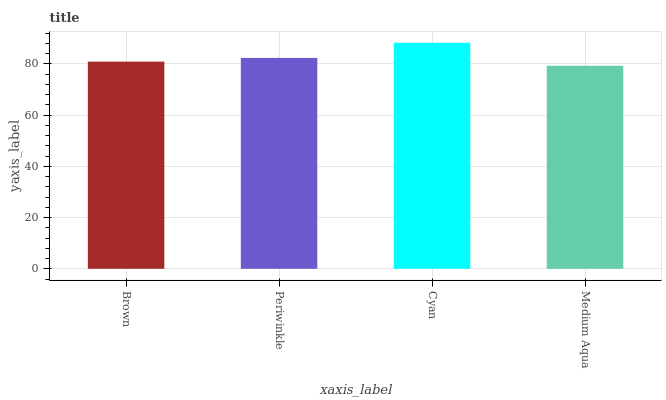Is Medium Aqua the minimum?
Answer yes or no. Yes. Is Cyan the maximum?
Answer yes or no. Yes. Is Periwinkle the minimum?
Answer yes or no. No. Is Periwinkle the maximum?
Answer yes or no. No. Is Periwinkle greater than Brown?
Answer yes or no. Yes. Is Brown less than Periwinkle?
Answer yes or no. Yes. Is Brown greater than Periwinkle?
Answer yes or no. No. Is Periwinkle less than Brown?
Answer yes or no. No. Is Periwinkle the high median?
Answer yes or no. Yes. Is Brown the low median?
Answer yes or no. Yes. Is Cyan the high median?
Answer yes or no. No. Is Cyan the low median?
Answer yes or no. No. 